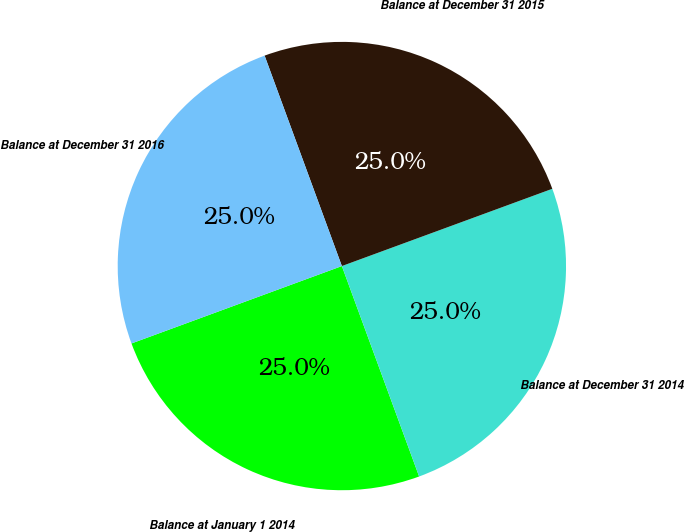Convert chart to OTSL. <chart><loc_0><loc_0><loc_500><loc_500><pie_chart><fcel>Balance at January 1 2014<fcel>Balance at December 31 2014<fcel>Balance at December 31 2015<fcel>Balance at December 31 2016<nl><fcel>24.99%<fcel>25.0%<fcel>25.0%<fcel>25.01%<nl></chart> 